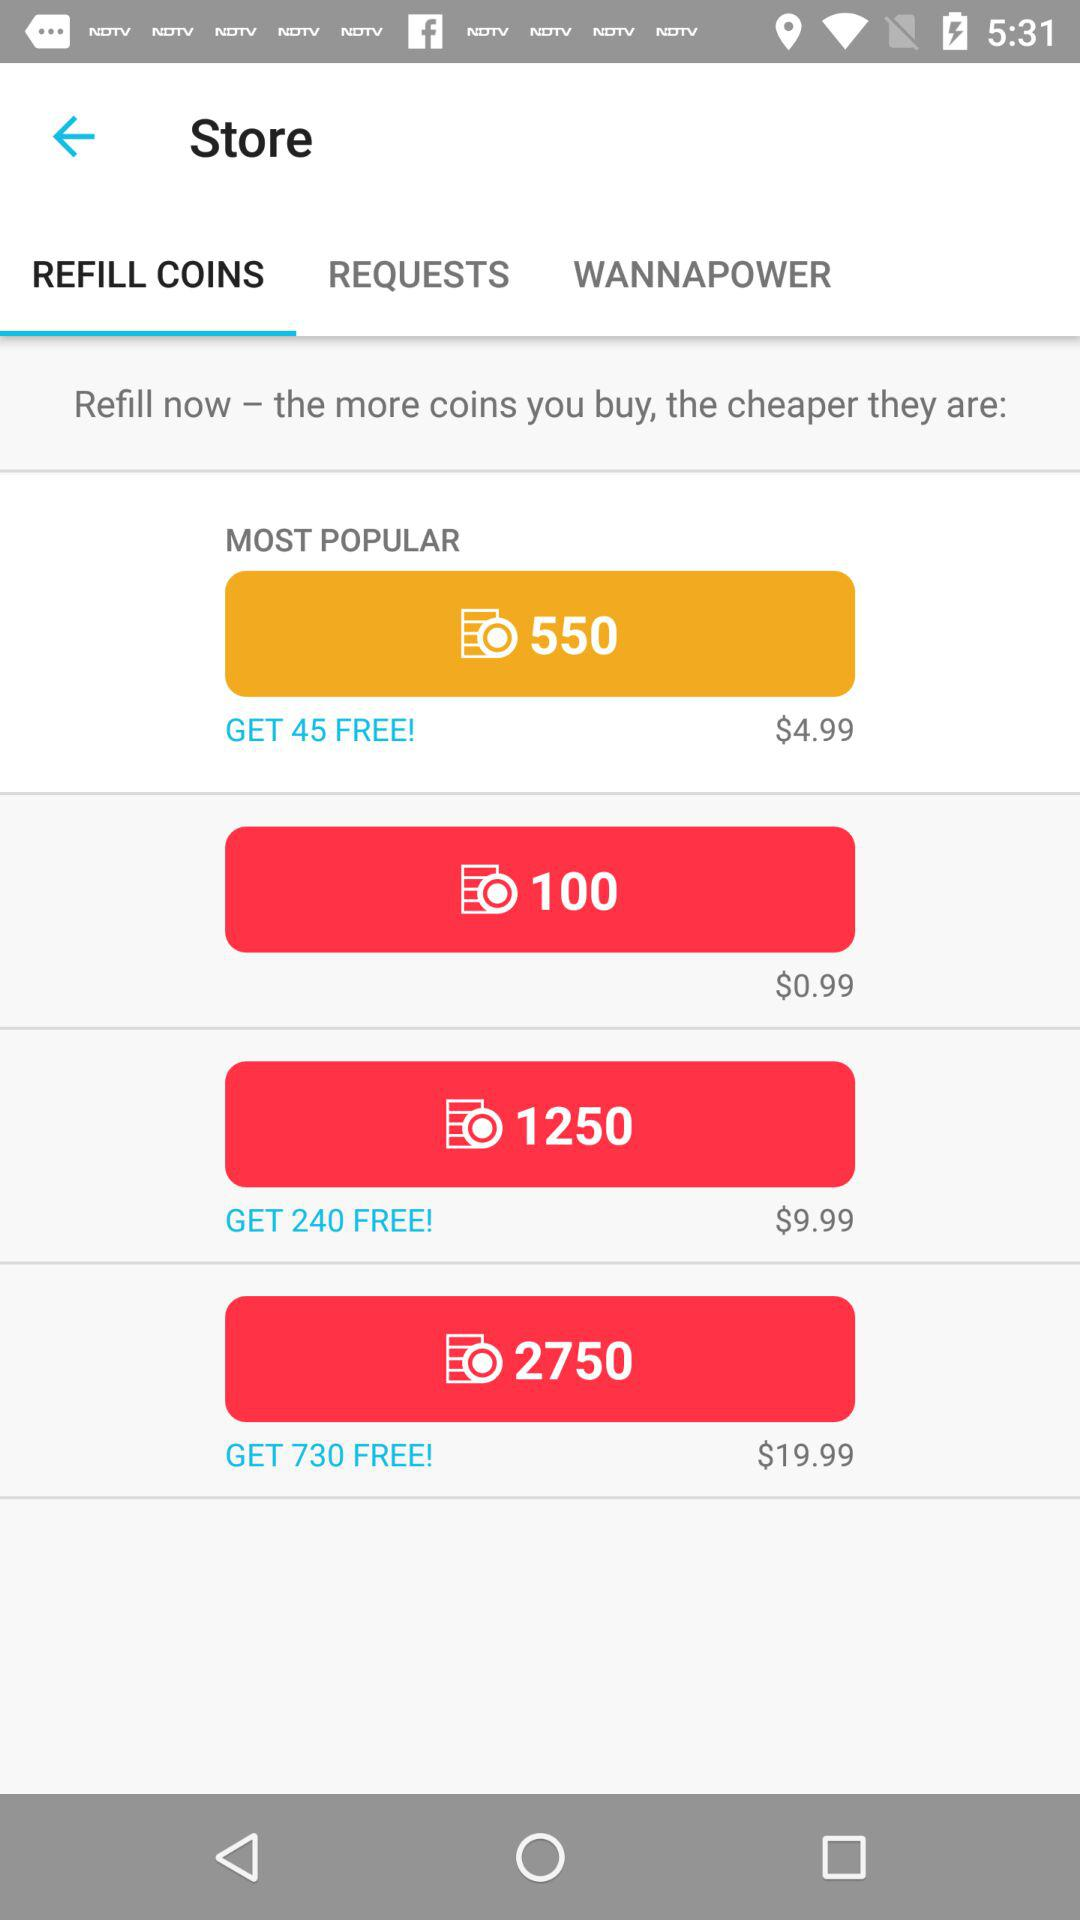How much more does the 2750 coin package cost than the 1250 coin package?
Answer the question using a single word or phrase. $10.00 